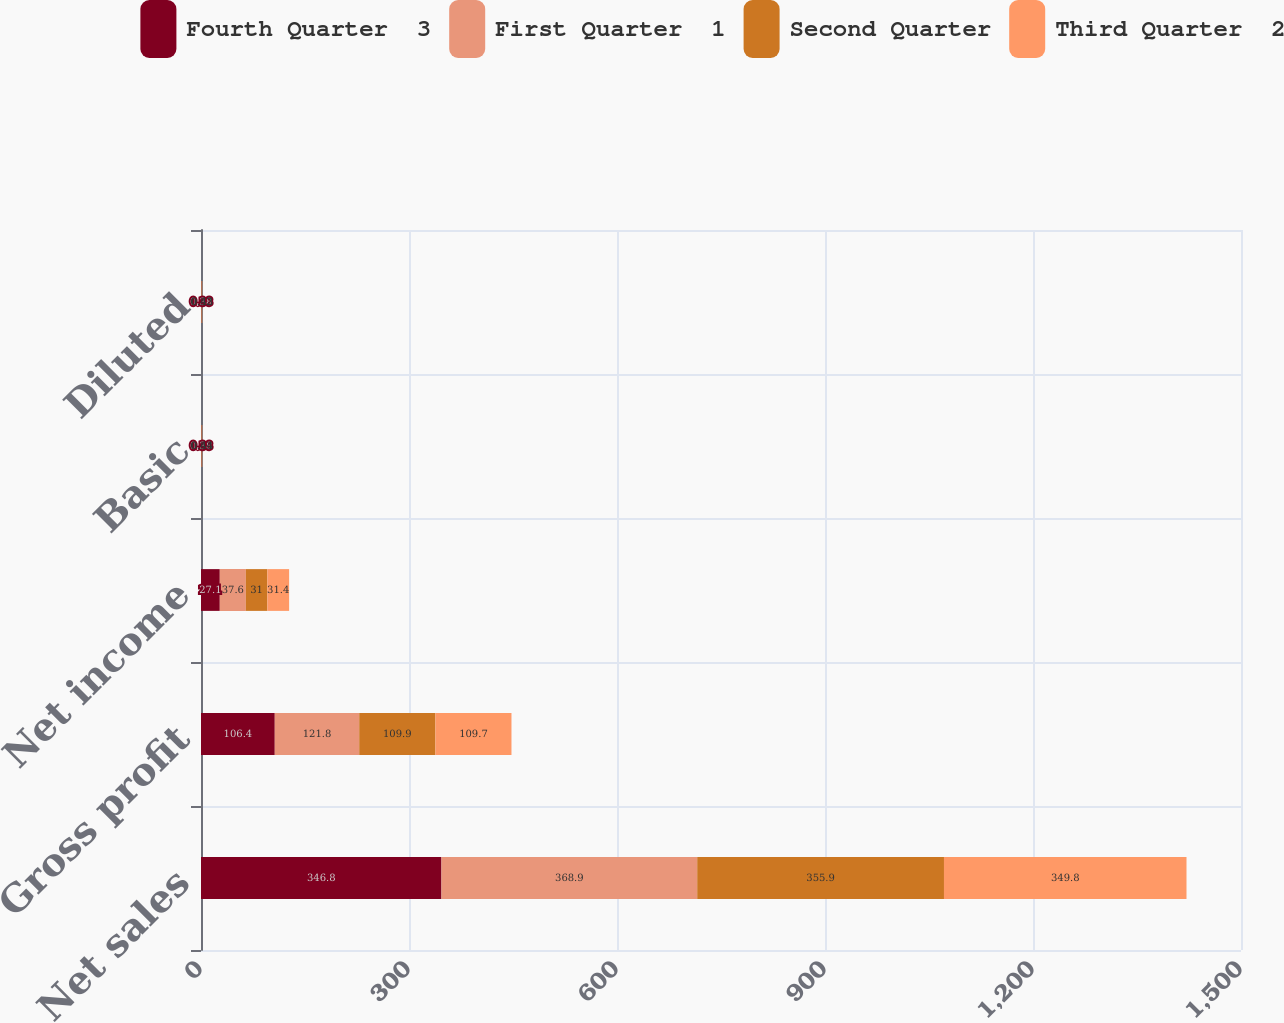<chart> <loc_0><loc_0><loc_500><loc_500><stacked_bar_chart><ecel><fcel>Net sales<fcel>Gross profit<fcel>Net income<fcel>Basic<fcel>Diluted<nl><fcel>Fourth Quarter  3<fcel>346.8<fcel>106.4<fcel>27.1<fcel>0.38<fcel>0.38<nl><fcel>First Quarter  1<fcel>368.9<fcel>121.8<fcel>37.6<fcel>0.53<fcel>0.52<nl><fcel>Second Quarter<fcel>355.9<fcel>109.9<fcel>31<fcel>0.44<fcel>0.43<nl><fcel>Third Quarter  2<fcel>349.8<fcel>109.7<fcel>31.4<fcel>0.44<fcel>0.43<nl></chart> 